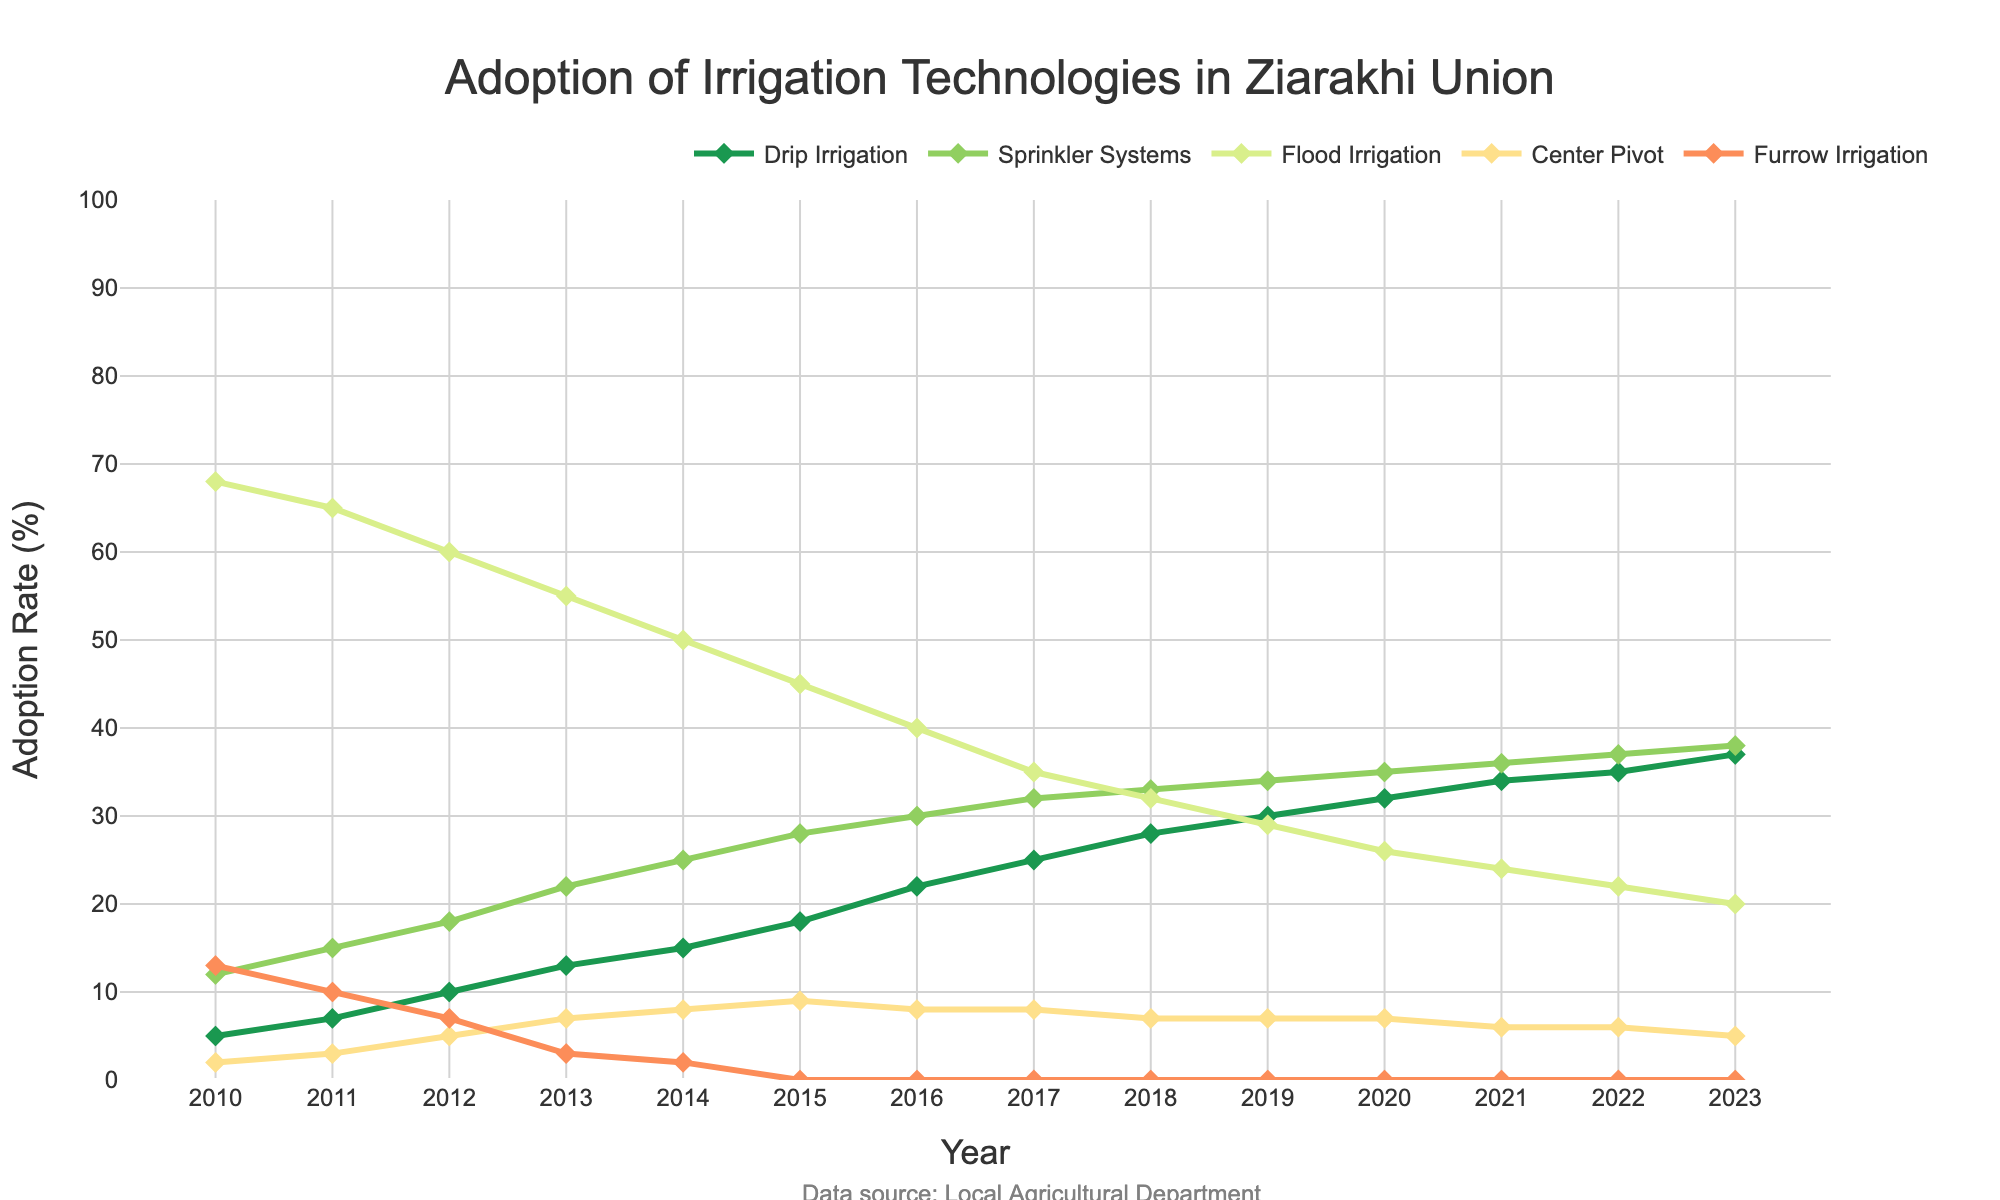What's the most adopted irrigation technology in 2010? In the year 2010, the adoption rates for the different irrigation technologies are represented as distinct data points on the plot. Flood Irrigation has the highest adoption rate, which is visually higher than the other technologies.
Answer: Flood Irrigation Which irrigation technology has shown a consistent increase in adoption rate from 2010 to 2023? By observing the lines on the plot for each technology, Drip Irrigation has shown a steady increase each year from 2010 to 2023 with a positive slope continuously.
Answer: Drip Irrigation How many technologies have an adoption rate of 0% by 2023? Looking at the plot in the year 2023, Furrow Irrigation and Flood Irrigation are at the bottom of the y-axis, indicating an adoption rate of 0%.
Answer: 2 What is the percentage difference between the highest and the lowest adoption rates in 2023? In 2023, the highest adoption rate is for Drip Irrigation (37%) and the lowest is for Furrow Irrigation and Flood Irrigation (0%). The difference is calculated as 37% - 0%.
Answer: 37% Which irrigation technology had a decline in its adoption rate starting from 2012? Examining the graph, Center Pivot shows a rise till 2015 and then remains steady or declines slightly after 2015. No technology explicitly declines from 2012.
Answer: None Between 2017 and 2022, which irrigation technology's adoption rate remained constant? Observing the plot between the years 2017 and 2022, Center Pivot's line remains flat, indicating a constant adoption rate during that period.
Answer: Center Pivot What is the average adoption rate of Sprinkler Systems from 2010 to 2015? The adoption rates for Sprinkler Systems from 2010 to 2015 are (12, 15, 18, 22, 25, 28). Adding these values gives a total of 120. The average is then 120 / 6.
Answer: 20 Which irrigation technology had the second highest adoption rate in 2020? From the 2020 data on the plot, the highest adoption rate is Drip Irrigation at 32%, followed by Sprinkler Systems at 35%.
Answer: Sprinkler Systems How does the adoption rate of Flood Irrigation change from 2010 to 2023? Observing the data points for Flood Irrigation from 2010 to 2023, the adoption rate decreases steadily from 68% in 2010 to 20% in 2023.
Answer: Decreases 